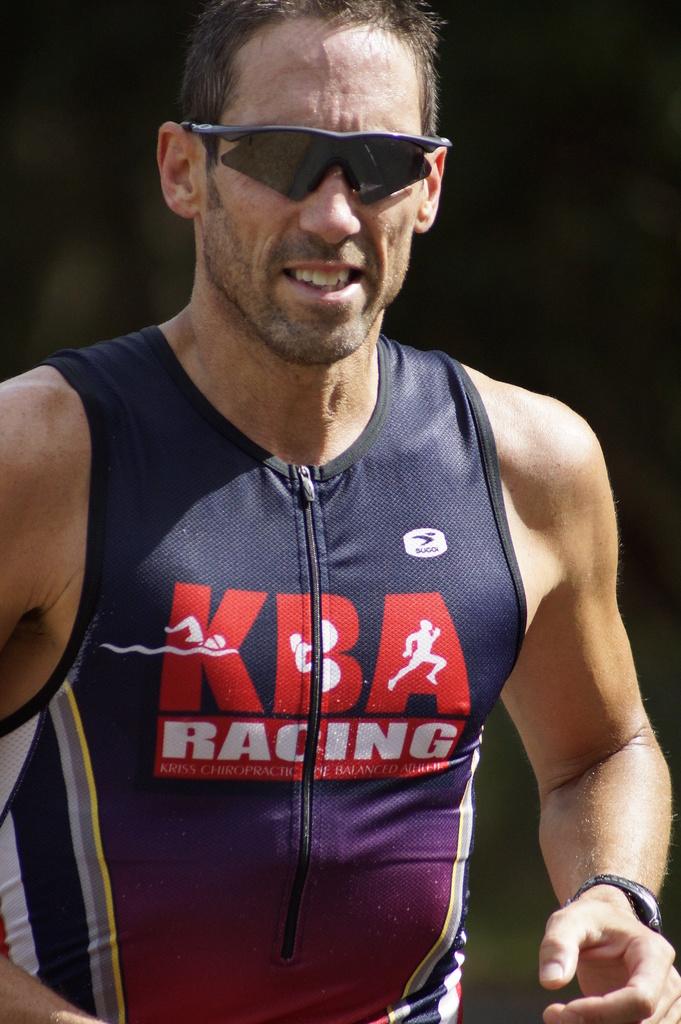What is the brand advertised on his shirt ?
Ensure brevity in your answer.  Kba racing. 